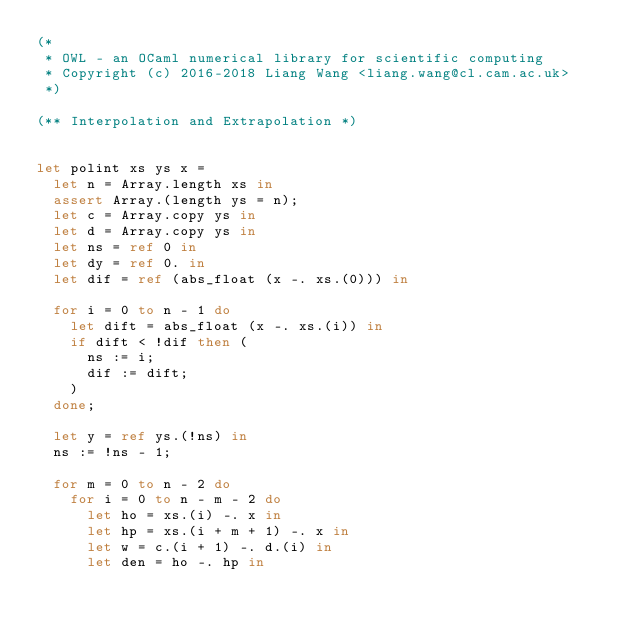<code> <loc_0><loc_0><loc_500><loc_500><_OCaml_>(*
 * OWL - an OCaml numerical library for scientific computing
 * Copyright (c) 2016-2018 Liang Wang <liang.wang@cl.cam.ac.uk>
 *)

(** Interpolation and Extrapolation *)


let polint xs ys x =
  let n = Array.length xs in
  assert Array.(length ys = n);
  let c = Array.copy ys in
  let d = Array.copy ys in
  let ns = ref 0 in
  let dy = ref 0. in
  let dif = ref (abs_float (x -. xs.(0))) in

  for i = 0 to n - 1 do
    let dift = abs_float (x -. xs.(i)) in
    if dift < !dif then (
      ns := i;
      dif := dift;
    )
  done;

  let y = ref ys.(!ns) in
  ns := !ns - 1;

  for m = 0 to n - 2 do
    for i = 0 to n - m - 2 do
      let ho = xs.(i) -. x in
      let hp = xs.(i + m + 1) -. x in
      let w = c.(i + 1) -. d.(i) in
      let den = ho -. hp in</code> 